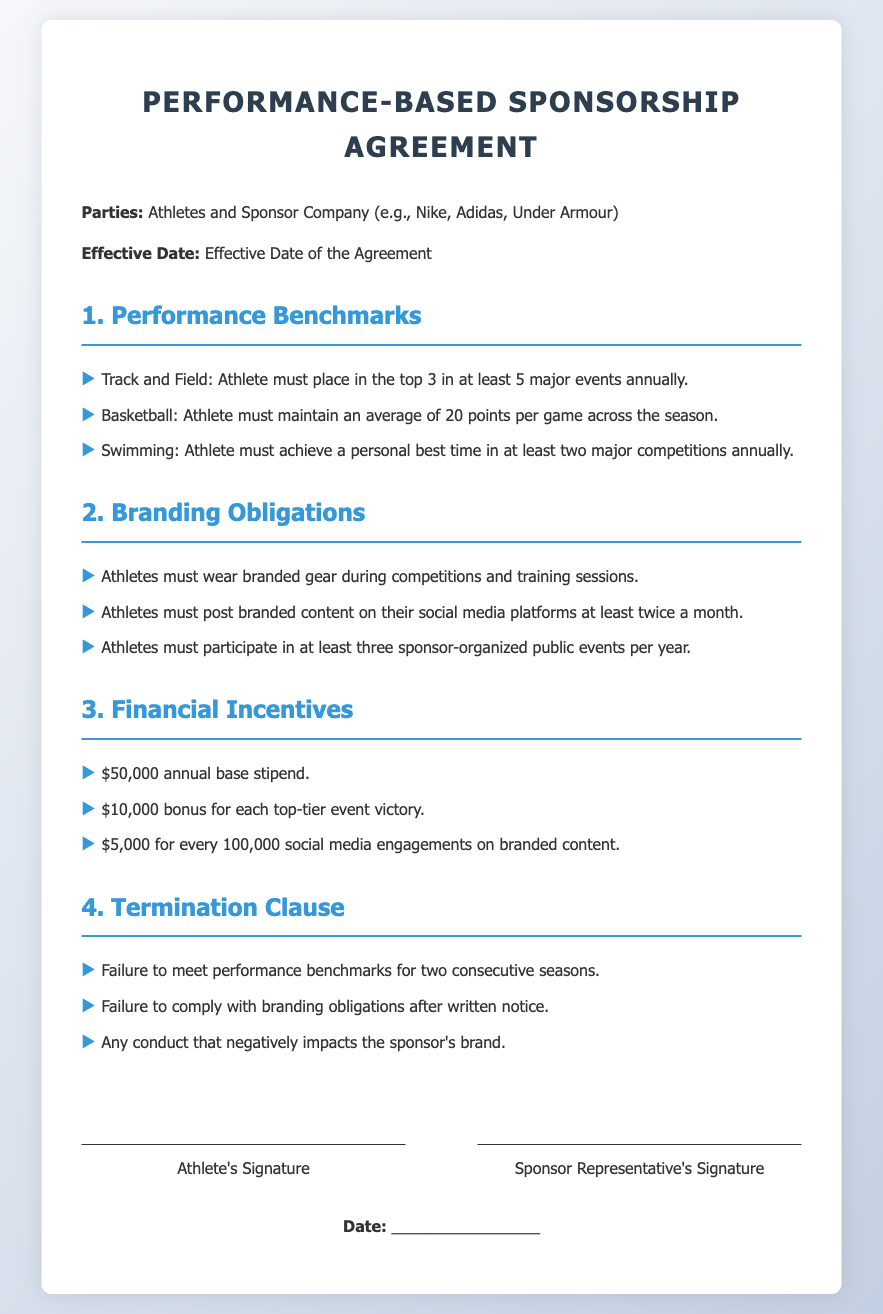What is the annual base stipend? The annual base stipend is specifically mentioned in the financial incentives section of the document.
Answer: $50,000 How many major events must a Track and Field athlete place in the top 3? This is outlined in the performance benchmarks for Track and Field athletes in the agreement.
Answer: 5 What is the bonus amount for each top-tier event victory? The financial incentives section details the bonus associated with victories in top-tier events.
Answer: $10,000 What are athletes required to do on their social media platforms? This obligation is specified in the branding obligations section of the document regarding branded content.
Answer: Post branded content at least twice a month How many sponsor-organized events must athletes participate in annually? This is outlined in the branding obligations section, indicating the minimum requirement for events.
Answer: 3 What could lead to the termination of the agreement? This question relates to the termination clause, which lists potential reasons for termination.
Answer: Failure to meet performance benchmarks What is the required average for a basketball player’s points per game? This is indicated in the performance benchmarks section, specifying expectations for basketball athletes.
Answer: 20 points Which companies are mentioned as potential sponsors? The contract opens with a mention of the types of sponsors that may engage with the athletes.
Answer: Nike, Adidas, Under Armour What date does the agreement become effective? This is stated near the beginning of the document, following the parties involved section.
Answer: Effective Date of the Agreement 